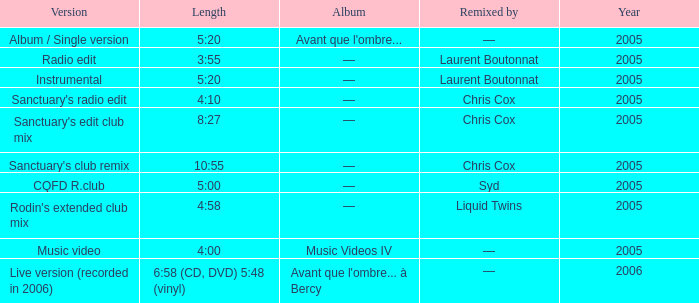What is the version shown for the Length of 4:58? Rodin's extended club mix. 